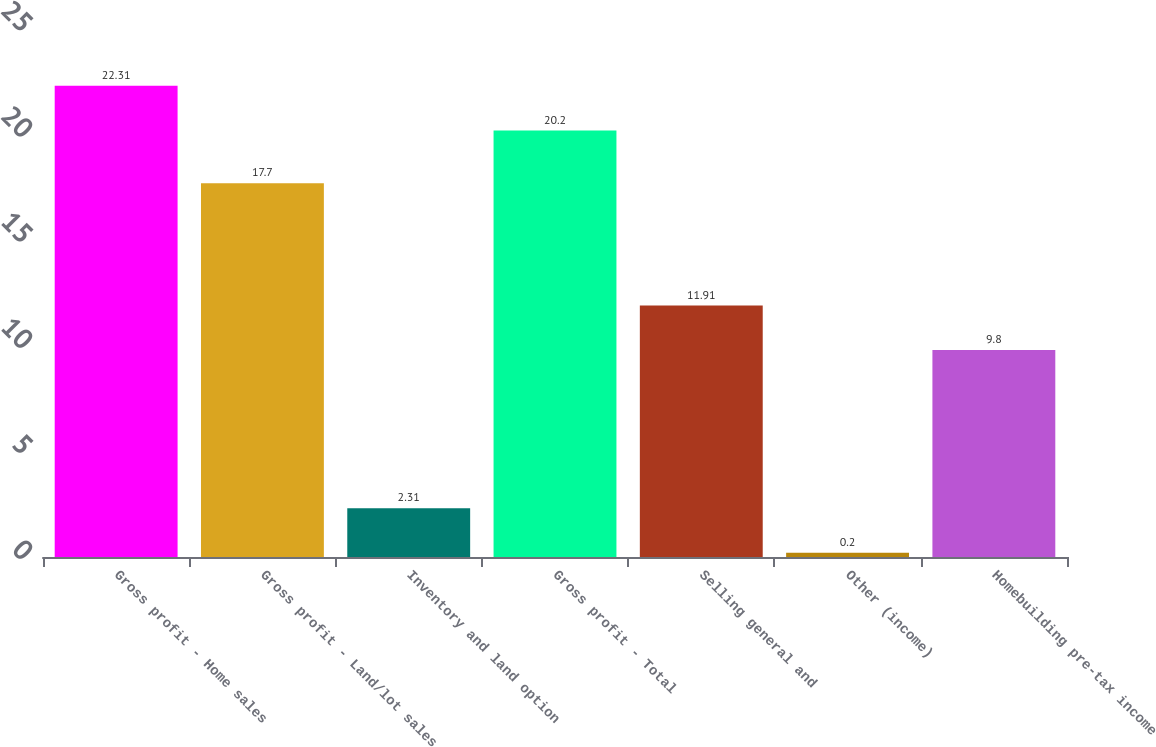Convert chart. <chart><loc_0><loc_0><loc_500><loc_500><bar_chart><fcel>Gross profit - Home sales<fcel>Gross profit - Land/lot sales<fcel>Inventory and land option<fcel>Gross profit - Total<fcel>Selling general and<fcel>Other (income)<fcel>Homebuilding pre-tax income<nl><fcel>22.31<fcel>17.7<fcel>2.31<fcel>20.2<fcel>11.91<fcel>0.2<fcel>9.8<nl></chart> 